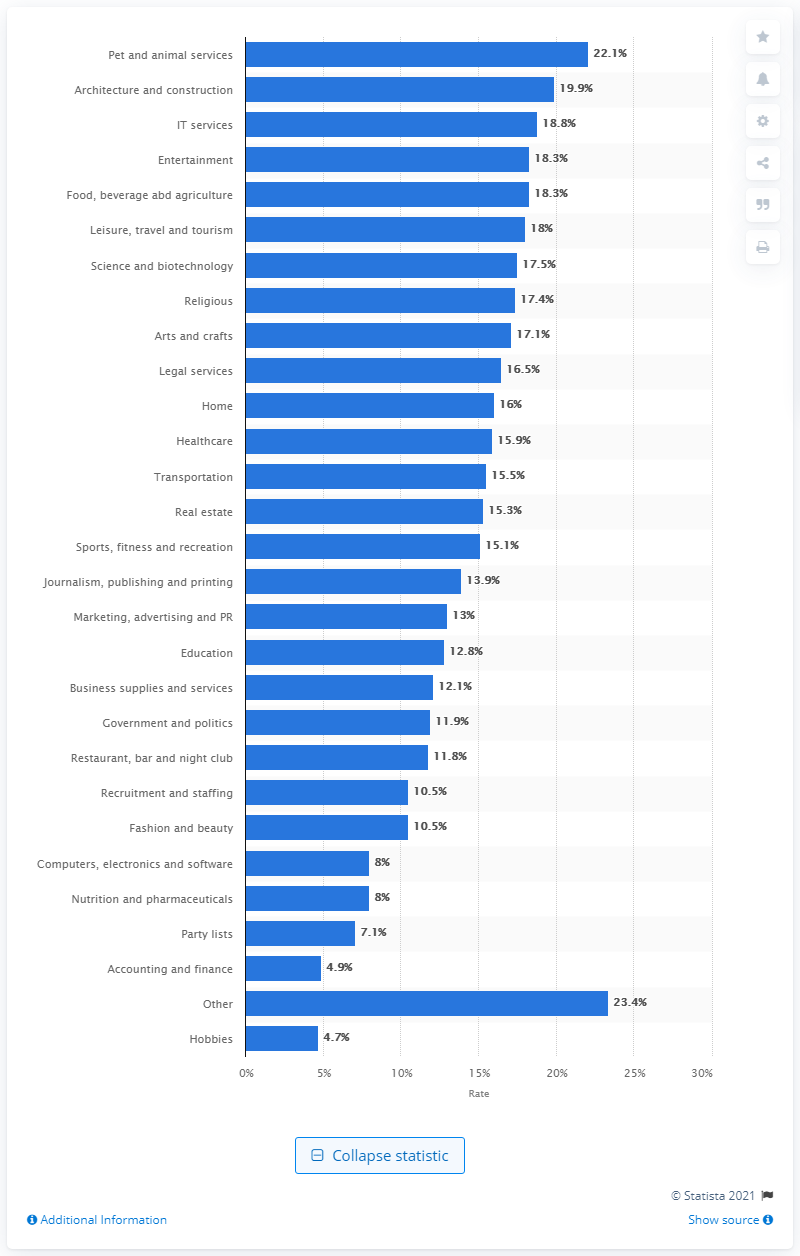Outline some significant characteristics in this image. The average open rate of e-mail messages in the fashion and beauty industry was 10.5%. 